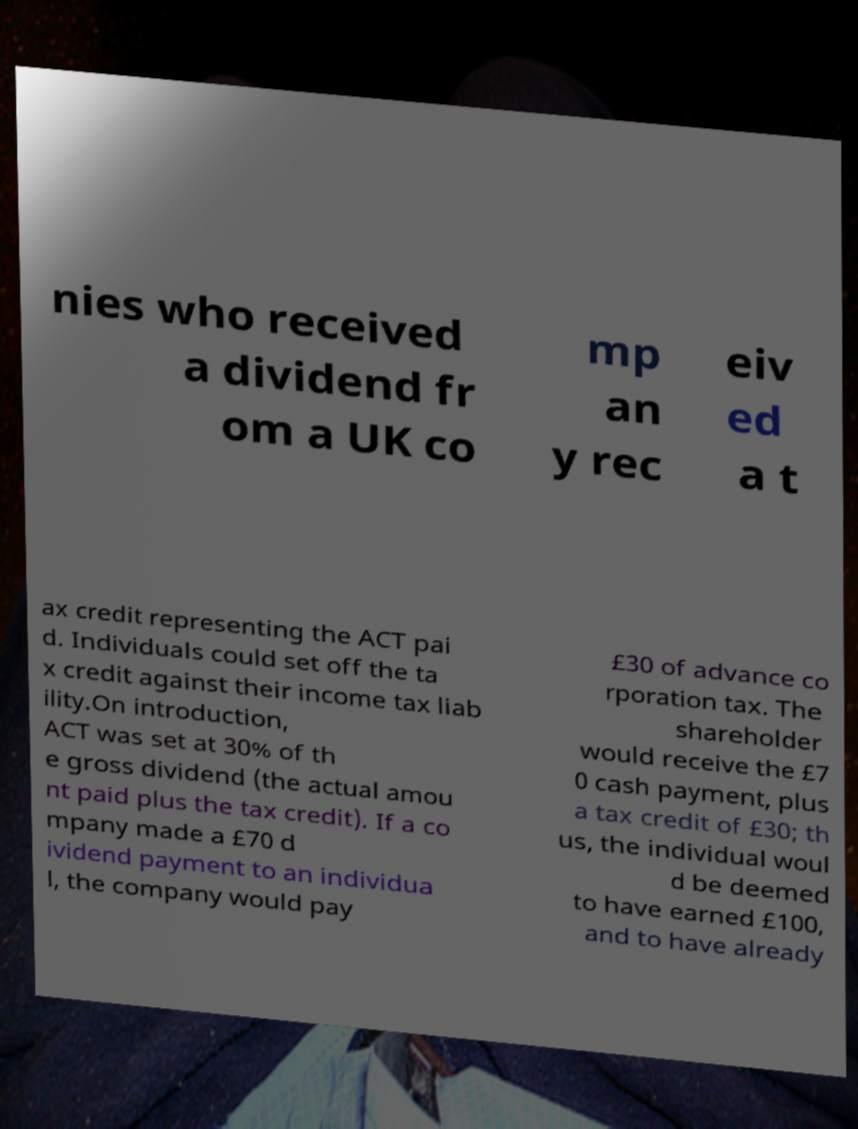Can you accurately transcribe the text from the provided image for me? nies who received a dividend fr om a UK co mp an y rec eiv ed a t ax credit representing the ACT pai d. Individuals could set off the ta x credit against their income tax liab ility.On introduction, ACT was set at 30% of th e gross dividend (the actual amou nt paid plus the tax credit). If a co mpany made a £70 d ividend payment to an individua l, the company would pay £30 of advance co rporation tax. The shareholder would receive the £7 0 cash payment, plus a tax credit of £30; th us, the individual woul d be deemed to have earned £100, and to have already 